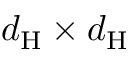Convert formula to latex. <formula><loc_0><loc_0><loc_500><loc_500>d _ { H } \times d _ { H }</formula> 